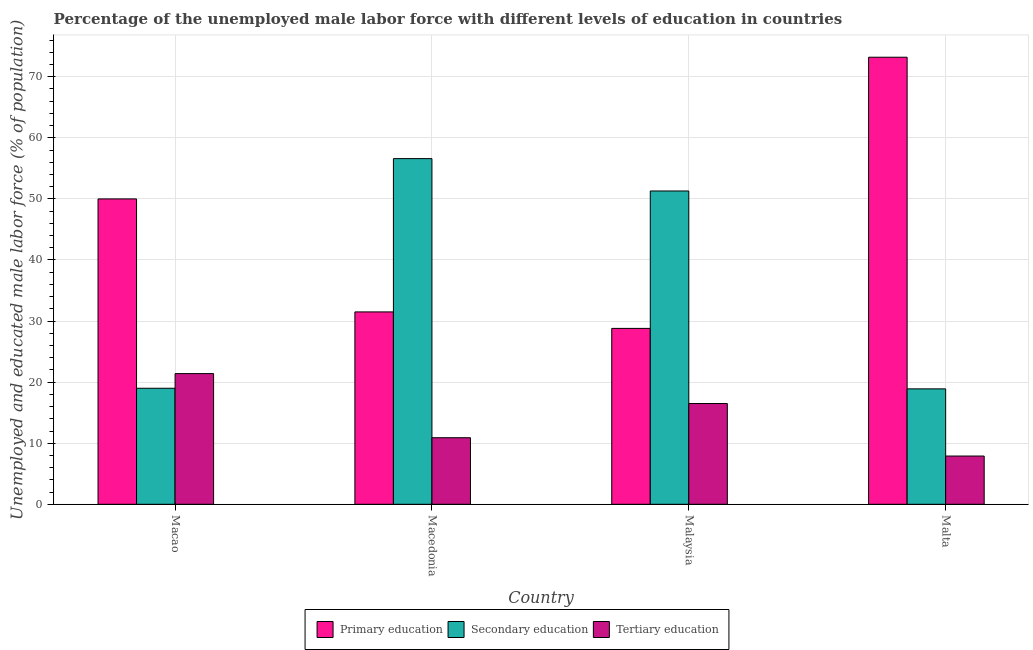How many different coloured bars are there?
Offer a terse response. 3. Are the number of bars per tick equal to the number of legend labels?
Your response must be concise. Yes. How many bars are there on the 1st tick from the right?
Offer a very short reply. 3. What is the label of the 4th group of bars from the left?
Offer a terse response. Malta. In how many cases, is the number of bars for a given country not equal to the number of legend labels?
Make the answer very short. 0. What is the percentage of male labor force who received tertiary education in Malaysia?
Keep it short and to the point. 16.5. Across all countries, what is the maximum percentage of male labor force who received tertiary education?
Offer a terse response. 21.4. Across all countries, what is the minimum percentage of male labor force who received primary education?
Give a very brief answer. 28.8. In which country was the percentage of male labor force who received secondary education maximum?
Provide a succinct answer. Macedonia. In which country was the percentage of male labor force who received tertiary education minimum?
Your answer should be very brief. Malta. What is the total percentage of male labor force who received tertiary education in the graph?
Your answer should be compact. 56.7. What is the difference between the percentage of male labor force who received primary education in Macedonia and that in Malaysia?
Your answer should be very brief. 2.7. What is the average percentage of male labor force who received tertiary education per country?
Provide a short and direct response. 14.17. What is the difference between the percentage of male labor force who received tertiary education and percentage of male labor force who received secondary education in Macao?
Your response must be concise. 2.4. What is the ratio of the percentage of male labor force who received tertiary education in Macao to that in Malaysia?
Ensure brevity in your answer.  1.3. Is the percentage of male labor force who received secondary education in Macao less than that in Malaysia?
Provide a succinct answer. Yes. Is the difference between the percentage of male labor force who received secondary education in Macao and Malaysia greater than the difference between the percentage of male labor force who received tertiary education in Macao and Malaysia?
Your response must be concise. No. What is the difference between the highest and the second highest percentage of male labor force who received primary education?
Keep it short and to the point. 23.2. What is the difference between the highest and the lowest percentage of male labor force who received tertiary education?
Provide a short and direct response. 13.5. In how many countries, is the percentage of male labor force who received secondary education greater than the average percentage of male labor force who received secondary education taken over all countries?
Provide a succinct answer. 2. What does the 3rd bar from the right in Malta represents?
Make the answer very short. Primary education. Is it the case that in every country, the sum of the percentage of male labor force who received primary education and percentage of male labor force who received secondary education is greater than the percentage of male labor force who received tertiary education?
Offer a terse response. Yes. How many bars are there?
Provide a succinct answer. 12. Are all the bars in the graph horizontal?
Keep it short and to the point. No. What is the difference between two consecutive major ticks on the Y-axis?
Make the answer very short. 10. Are the values on the major ticks of Y-axis written in scientific E-notation?
Your answer should be very brief. No. Does the graph contain grids?
Your answer should be compact. Yes. How many legend labels are there?
Keep it short and to the point. 3. How are the legend labels stacked?
Make the answer very short. Horizontal. What is the title of the graph?
Your answer should be compact. Percentage of the unemployed male labor force with different levels of education in countries. What is the label or title of the Y-axis?
Your response must be concise. Unemployed and educated male labor force (% of population). What is the Unemployed and educated male labor force (% of population) in Secondary education in Macao?
Your response must be concise. 19. What is the Unemployed and educated male labor force (% of population) of Tertiary education in Macao?
Offer a very short reply. 21.4. What is the Unemployed and educated male labor force (% of population) of Primary education in Macedonia?
Your answer should be very brief. 31.5. What is the Unemployed and educated male labor force (% of population) in Secondary education in Macedonia?
Make the answer very short. 56.6. What is the Unemployed and educated male labor force (% of population) in Tertiary education in Macedonia?
Offer a very short reply. 10.9. What is the Unemployed and educated male labor force (% of population) of Primary education in Malaysia?
Your answer should be compact. 28.8. What is the Unemployed and educated male labor force (% of population) of Secondary education in Malaysia?
Give a very brief answer. 51.3. What is the Unemployed and educated male labor force (% of population) of Tertiary education in Malaysia?
Keep it short and to the point. 16.5. What is the Unemployed and educated male labor force (% of population) of Primary education in Malta?
Give a very brief answer. 73.2. What is the Unemployed and educated male labor force (% of population) in Secondary education in Malta?
Offer a very short reply. 18.9. What is the Unemployed and educated male labor force (% of population) of Tertiary education in Malta?
Ensure brevity in your answer.  7.9. Across all countries, what is the maximum Unemployed and educated male labor force (% of population) of Primary education?
Offer a terse response. 73.2. Across all countries, what is the maximum Unemployed and educated male labor force (% of population) of Secondary education?
Ensure brevity in your answer.  56.6. Across all countries, what is the maximum Unemployed and educated male labor force (% of population) in Tertiary education?
Your response must be concise. 21.4. Across all countries, what is the minimum Unemployed and educated male labor force (% of population) in Primary education?
Your answer should be very brief. 28.8. Across all countries, what is the minimum Unemployed and educated male labor force (% of population) in Secondary education?
Offer a terse response. 18.9. Across all countries, what is the minimum Unemployed and educated male labor force (% of population) in Tertiary education?
Make the answer very short. 7.9. What is the total Unemployed and educated male labor force (% of population) of Primary education in the graph?
Your answer should be very brief. 183.5. What is the total Unemployed and educated male labor force (% of population) of Secondary education in the graph?
Your answer should be compact. 145.8. What is the total Unemployed and educated male labor force (% of population) in Tertiary education in the graph?
Provide a succinct answer. 56.7. What is the difference between the Unemployed and educated male labor force (% of population) of Primary education in Macao and that in Macedonia?
Give a very brief answer. 18.5. What is the difference between the Unemployed and educated male labor force (% of population) in Secondary education in Macao and that in Macedonia?
Give a very brief answer. -37.6. What is the difference between the Unemployed and educated male labor force (% of population) in Primary education in Macao and that in Malaysia?
Offer a terse response. 21.2. What is the difference between the Unemployed and educated male labor force (% of population) of Secondary education in Macao and that in Malaysia?
Provide a succinct answer. -32.3. What is the difference between the Unemployed and educated male labor force (% of population) in Tertiary education in Macao and that in Malaysia?
Your response must be concise. 4.9. What is the difference between the Unemployed and educated male labor force (% of population) of Primary education in Macao and that in Malta?
Offer a terse response. -23.2. What is the difference between the Unemployed and educated male labor force (% of population) of Tertiary education in Macao and that in Malta?
Offer a very short reply. 13.5. What is the difference between the Unemployed and educated male labor force (% of population) of Secondary education in Macedonia and that in Malaysia?
Give a very brief answer. 5.3. What is the difference between the Unemployed and educated male labor force (% of population) in Tertiary education in Macedonia and that in Malaysia?
Provide a short and direct response. -5.6. What is the difference between the Unemployed and educated male labor force (% of population) of Primary education in Macedonia and that in Malta?
Ensure brevity in your answer.  -41.7. What is the difference between the Unemployed and educated male labor force (% of population) of Secondary education in Macedonia and that in Malta?
Your response must be concise. 37.7. What is the difference between the Unemployed and educated male labor force (% of population) in Tertiary education in Macedonia and that in Malta?
Ensure brevity in your answer.  3. What is the difference between the Unemployed and educated male labor force (% of population) in Primary education in Malaysia and that in Malta?
Your answer should be compact. -44.4. What is the difference between the Unemployed and educated male labor force (% of population) of Secondary education in Malaysia and that in Malta?
Make the answer very short. 32.4. What is the difference between the Unemployed and educated male labor force (% of population) of Tertiary education in Malaysia and that in Malta?
Your answer should be very brief. 8.6. What is the difference between the Unemployed and educated male labor force (% of population) of Primary education in Macao and the Unemployed and educated male labor force (% of population) of Secondary education in Macedonia?
Ensure brevity in your answer.  -6.6. What is the difference between the Unemployed and educated male labor force (% of population) of Primary education in Macao and the Unemployed and educated male labor force (% of population) of Tertiary education in Macedonia?
Offer a terse response. 39.1. What is the difference between the Unemployed and educated male labor force (% of population) of Secondary education in Macao and the Unemployed and educated male labor force (% of population) of Tertiary education in Macedonia?
Your answer should be compact. 8.1. What is the difference between the Unemployed and educated male labor force (% of population) of Primary education in Macao and the Unemployed and educated male labor force (% of population) of Secondary education in Malaysia?
Give a very brief answer. -1.3. What is the difference between the Unemployed and educated male labor force (% of population) in Primary education in Macao and the Unemployed and educated male labor force (% of population) in Tertiary education in Malaysia?
Offer a terse response. 33.5. What is the difference between the Unemployed and educated male labor force (% of population) of Secondary education in Macao and the Unemployed and educated male labor force (% of population) of Tertiary education in Malaysia?
Keep it short and to the point. 2.5. What is the difference between the Unemployed and educated male labor force (% of population) of Primary education in Macao and the Unemployed and educated male labor force (% of population) of Secondary education in Malta?
Your response must be concise. 31.1. What is the difference between the Unemployed and educated male labor force (% of population) of Primary education in Macao and the Unemployed and educated male labor force (% of population) of Tertiary education in Malta?
Offer a very short reply. 42.1. What is the difference between the Unemployed and educated male labor force (% of population) in Primary education in Macedonia and the Unemployed and educated male labor force (% of population) in Secondary education in Malaysia?
Your answer should be compact. -19.8. What is the difference between the Unemployed and educated male labor force (% of population) in Secondary education in Macedonia and the Unemployed and educated male labor force (% of population) in Tertiary education in Malaysia?
Your response must be concise. 40.1. What is the difference between the Unemployed and educated male labor force (% of population) in Primary education in Macedonia and the Unemployed and educated male labor force (% of population) in Secondary education in Malta?
Keep it short and to the point. 12.6. What is the difference between the Unemployed and educated male labor force (% of population) of Primary education in Macedonia and the Unemployed and educated male labor force (% of population) of Tertiary education in Malta?
Provide a short and direct response. 23.6. What is the difference between the Unemployed and educated male labor force (% of population) of Secondary education in Macedonia and the Unemployed and educated male labor force (% of population) of Tertiary education in Malta?
Your response must be concise. 48.7. What is the difference between the Unemployed and educated male labor force (% of population) of Primary education in Malaysia and the Unemployed and educated male labor force (% of population) of Tertiary education in Malta?
Keep it short and to the point. 20.9. What is the difference between the Unemployed and educated male labor force (% of population) in Secondary education in Malaysia and the Unemployed and educated male labor force (% of population) in Tertiary education in Malta?
Ensure brevity in your answer.  43.4. What is the average Unemployed and educated male labor force (% of population) of Primary education per country?
Keep it short and to the point. 45.88. What is the average Unemployed and educated male labor force (% of population) in Secondary education per country?
Offer a terse response. 36.45. What is the average Unemployed and educated male labor force (% of population) in Tertiary education per country?
Offer a very short reply. 14.18. What is the difference between the Unemployed and educated male labor force (% of population) in Primary education and Unemployed and educated male labor force (% of population) in Secondary education in Macao?
Ensure brevity in your answer.  31. What is the difference between the Unemployed and educated male labor force (% of population) of Primary education and Unemployed and educated male labor force (% of population) of Tertiary education in Macao?
Your answer should be compact. 28.6. What is the difference between the Unemployed and educated male labor force (% of population) of Primary education and Unemployed and educated male labor force (% of population) of Secondary education in Macedonia?
Offer a terse response. -25.1. What is the difference between the Unemployed and educated male labor force (% of population) in Primary education and Unemployed and educated male labor force (% of population) in Tertiary education in Macedonia?
Provide a short and direct response. 20.6. What is the difference between the Unemployed and educated male labor force (% of population) in Secondary education and Unemployed and educated male labor force (% of population) in Tertiary education in Macedonia?
Provide a short and direct response. 45.7. What is the difference between the Unemployed and educated male labor force (% of population) of Primary education and Unemployed and educated male labor force (% of population) of Secondary education in Malaysia?
Make the answer very short. -22.5. What is the difference between the Unemployed and educated male labor force (% of population) in Secondary education and Unemployed and educated male labor force (% of population) in Tertiary education in Malaysia?
Give a very brief answer. 34.8. What is the difference between the Unemployed and educated male labor force (% of population) in Primary education and Unemployed and educated male labor force (% of population) in Secondary education in Malta?
Offer a terse response. 54.3. What is the difference between the Unemployed and educated male labor force (% of population) of Primary education and Unemployed and educated male labor force (% of population) of Tertiary education in Malta?
Ensure brevity in your answer.  65.3. What is the ratio of the Unemployed and educated male labor force (% of population) in Primary education in Macao to that in Macedonia?
Offer a very short reply. 1.59. What is the ratio of the Unemployed and educated male labor force (% of population) of Secondary education in Macao to that in Macedonia?
Offer a terse response. 0.34. What is the ratio of the Unemployed and educated male labor force (% of population) of Tertiary education in Macao to that in Macedonia?
Provide a succinct answer. 1.96. What is the ratio of the Unemployed and educated male labor force (% of population) in Primary education in Macao to that in Malaysia?
Offer a terse response. 1.74. What is the ratio of the Unemployed and educated male labor force (% of population) of Secondary education in Macao to that in Malaysia?
Keep it short and to the point. 0.37. What is the ratio of the Unemployed and educated male labor force (% of population) in Tertiary education in Macao to that in Malaysia?
Provide a succinct answer. 1.3. What is the ratio of the Unemployed and educated male labor force (% of population) of Primary education in Macao to that in Malta?
Your answer should be very brief. 0.68. What is the ratio of the Unemployed and educated male labor force (% of population) of Secondary education in Macao to that in Malta?
Keep it short and to the point. 1.01. What is the ratio of the Unemployed and educated male labor force (% of population) of Tertiary education in Macao to that in Malta?
Offer a very short reply. 2.71. What is the ratio of the Unemployed and educated male labor force (% of population) in Primary education in Macedonia to that in Malaysia?
Give a very brief answer. 1.09. What is the ratio of the Unemployed and educated male labor force (% of population) of Secondary education in Macedonia to that in Malaysia?
Give a very brief answer. 1.1. What is the ratio of the Unemployed and educated male labor force (% of population) of Tertiary education in Macedonia to that in Malaysia?
Keep it short and to the point. 0.66. What is the ratio of the Unemployed and educated male labor force (% of population) of Primary education in Macedonia to that in Malta?
Offer a terse response. 0.43. What is the ratio of the Unemployed and educated male labor force (% of population) of Secondary education in Macedonia to that in Malta?
Your answer should be very brief. 2.99. What is the ratio of the Unemployed and educated male labor force (% of population) of Tertiary education in Macedonia to that in Malta?
Make the answer very short. 1.38. What is the ratio of the Unemployed and educated male labor force (% of population) of Primary education in Malaysia to that in Malta?
Provide a short and direct response. 0.39. What is the ratio of the Unemployed and educated male labor force (% of population) in Secondary education in Malaysia to that in Malta?
Your response must be concise. 2.71. What is the ratio of the Unemployed and educated male labor force (% of population) of Tertiary education in Malaysia to that in Malta?
Ensure brevity in your answer.  2.09. What is the difference between the highest and the second highest Unemployed and educated male labor force (% of population) of Primary education?
Provide a succinct answer. 23.2. What is the difference between the highest and the second highest Unemployed and educated male labor force (% of population) of Secondary education?
Provide a succinct answer. 5.3. What is the difference between the highest and the lowest Unemployed and educated male labor force (% of population) in Primary education?
Provide a succinct answer. 44.4. What is the difference between the highest and the lowest Unemployed and educated male labor force (% of population) in Secondary education?
Make the answer very short. 37.7. 